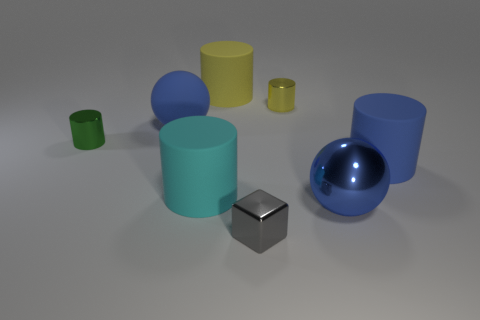What is the color of the rubber object that is the same shape as the big metallic thing?
Your answer should be very brief. Blue. What shape is the matte object that is the same color as the big matte ball?
Give a very brief answer. Cylinder. Do the blue thing that is behind the green object and the metal object left of the block have the same size?
Your response must be concise. No. There is a small object that is to the right of the green cylinder and behind the tiny gray shiny thing; what material is it?
Give a very brief answer. Metal. There is a shiny ball that is the same color as the big rubber ball; what is its size?
Keep it short and to the point. Large. How many other objects are the same size as the gray object?
Give a very brief answer. 2. What is the material of the big blue sphere that is in front of the big cyan rubber object?
Offer a very short reply. Metal. Do the small green thing and the blue shiny thing have the same shape?
Provide a succinct answer. No. What number of other things are there of the same shape as the small gray metallic object?
Your answer should be very brief. 0. There is a small thing in front of the large blue cylinder; what color is it?
Offer a very short reply. Gray. 